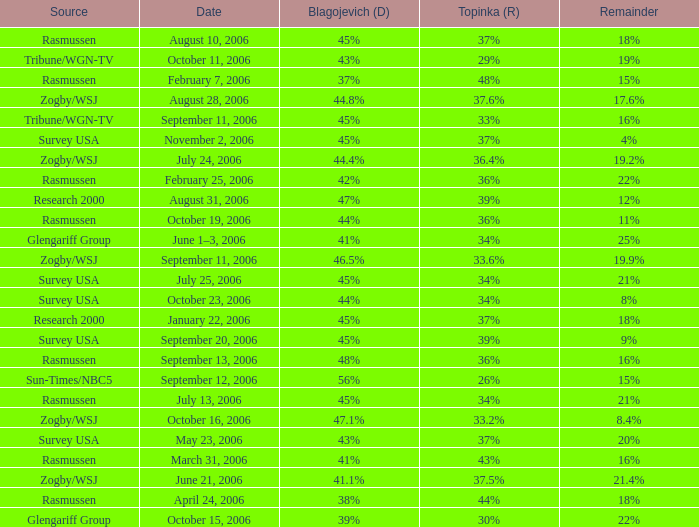Which Blagojevich (D) has a Source of zogby/wsj, and a Date of october 16, 2006? 47.1%. 